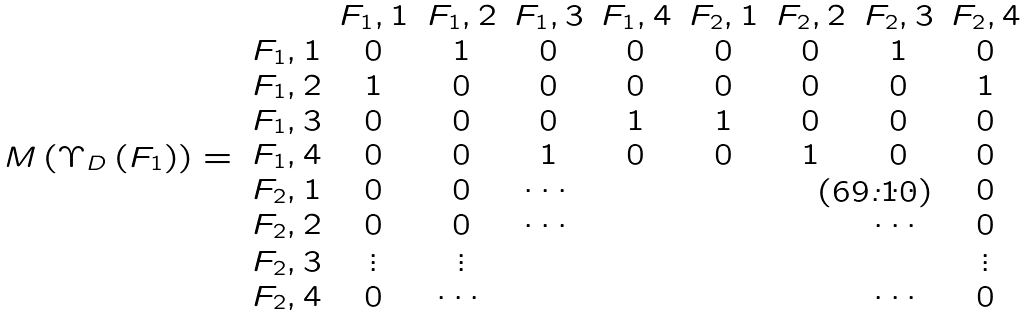Convert formula to latex. <formula><loc_0><loc_0><loc_500><loc_500>M \left ( \Upsilon _ { D } \left ( F _ { 1 } \right ) \right ) = \begin{array} { c c c c c c c c c } & F _ { 1 } , 1 & F _ { 1 } , 2 & F _ { 1 } , 3 & F _ { 1 } , 4 & F _ { 2 } , 1 & F _ { 2 } , 2 & F _ { 2 } , 3 & F _ { 2 } , 4 \\ F _ { 1 } , 1 & 0 & 1 & 0 & 0 & 0 & 0 & 1 & 0 \\ F _ { 1 } , 2 & 1 & 0 & 0 & 0 & 0 & 0 & 0 & 1 \\ F _ { 1 } , 3 & 0 & 0 & 0 & 1 & 1 & 0 & 0 & 0 \\ F _ { 1 } , 4 & 0 & 0 & 1 & 0 & 0 & 1 & 0 & 0 \\ F _ { 2 } , 1 & 0 & 0 & \cdots & & & & \cdots & 0 \\ F _ { 2 } , 2 & 0 & 0 & \cdots & & & & \cdots & 0 \\ F _ { 2 } , 3 & \vdots & \vdots & & & & & & \vdots \\ F _ { 2 } , 4 & 0 & \cdots & & & & & \cdots & 0 \end{array}</formula> 